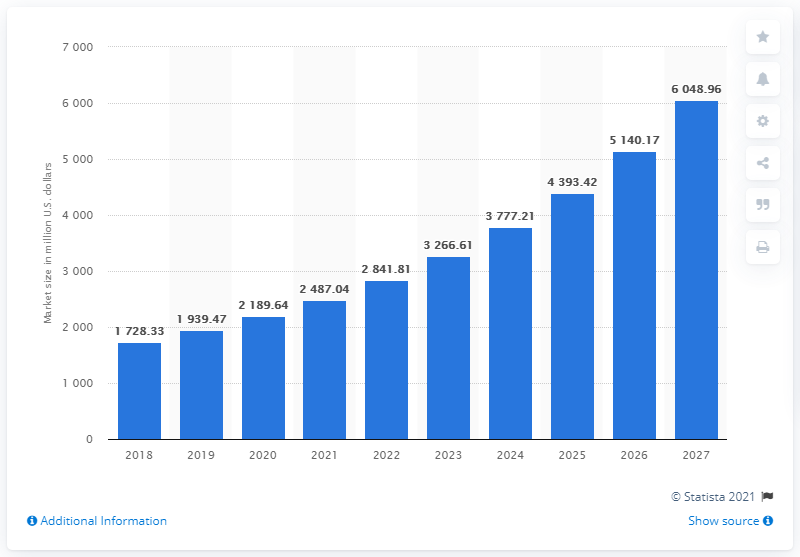Give some essential details in this illustration. The track and trace solutions market is expected to end in 2027. The total revenues of the track and trace solutions market in 2018 were approximately 1,728.33. 